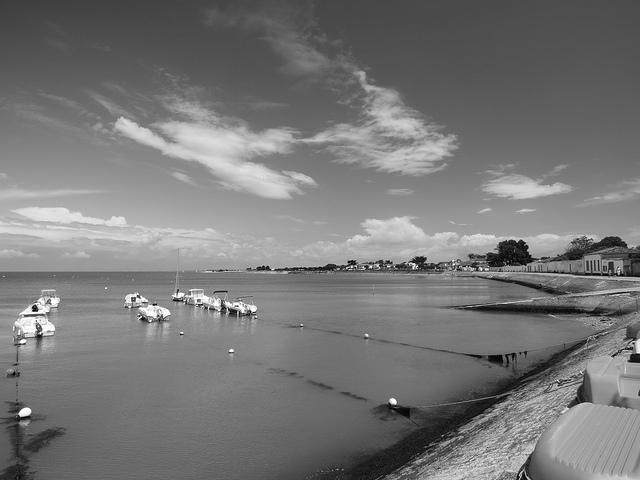How many boats are in this picture?
Keep it brief. 8. What are the boats designed for?
Write a very short answer. Fishing. Is this black and white?
Answer briefly. Yes. Are there many clouds in the sky?
Answer briefly. Yes. 